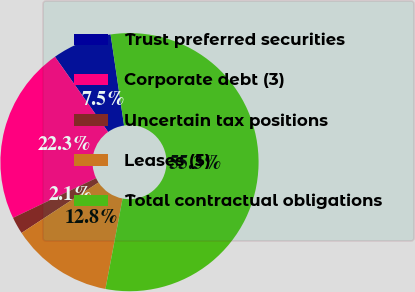<chart> <loc_0><loc_0><loc_500><loc_500><pie_chart><fcel>Trust preferred securities<fcel>Corporate debt (3)<fcel>Uncertain tax positions<fcel>Leases (5)<fcel>Total contractual obligations<nl><fcel>7.46%<fcel>22.3%<fcel>2.14%<fcel>12.78%<fcel>55.32%<nl></chart> 